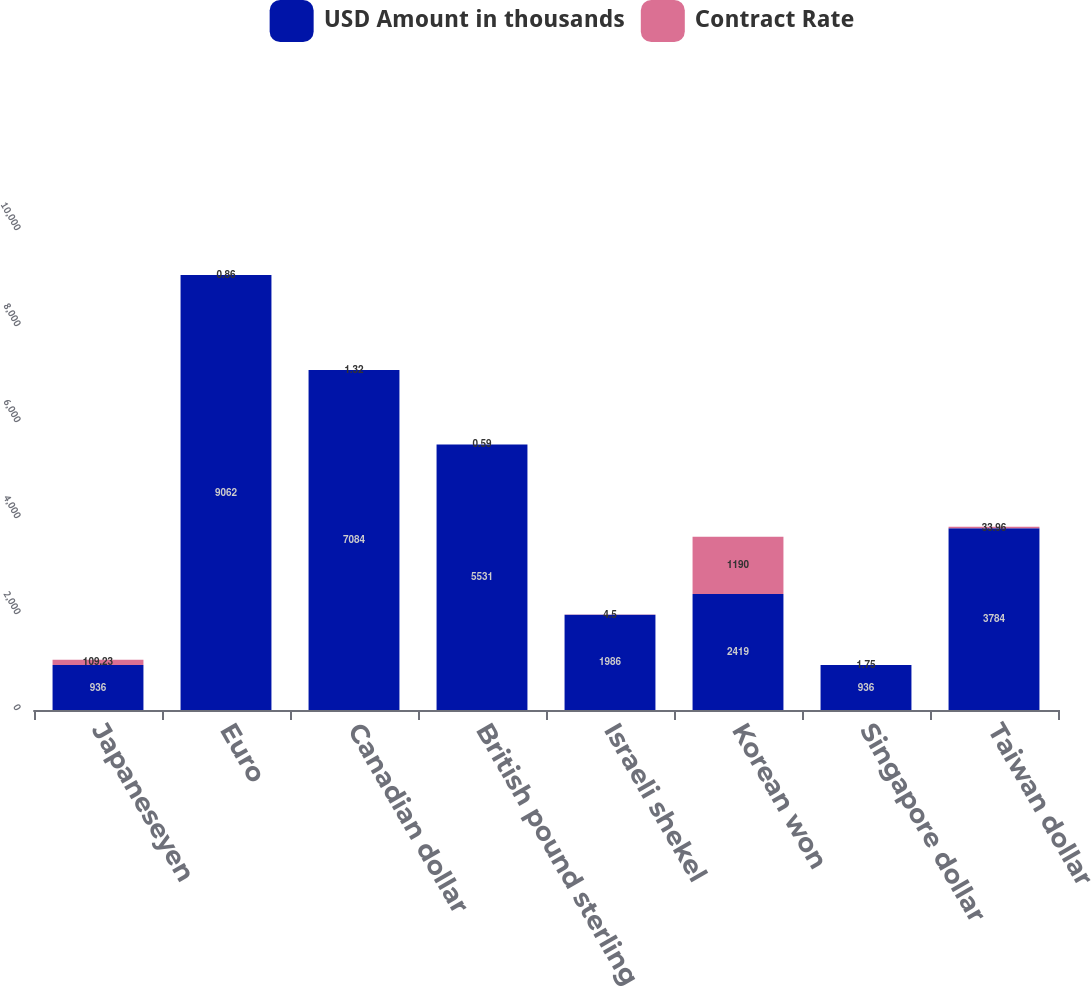Convert chart. <chart><loc_0><loc_0><loc_500><loc_500><stacked_bar_chart><ecel><fcel>Japaneseyen<fcel>Euro<fcel>Canadian dollar<fcel>British pound sterling<fcel>Israeli shekel<fcel>Korean won<fcel>Singapore dollar<fcel>Taiwan dollar<nl><fcel>USD Amount in thousands<fcel>936<fcel>9062<fcel>7084<fcel>5531<fcel>1986<fcel>2419<fcel>936<fcel>3784<nl><fcel>Contract Rate<fcel>109.23<fcel>0.86<fcel>1.32<fcel>0.59<fcel>4.5<fcel>1190<fcel>1.75<fcel>33.96<nl></chart> 